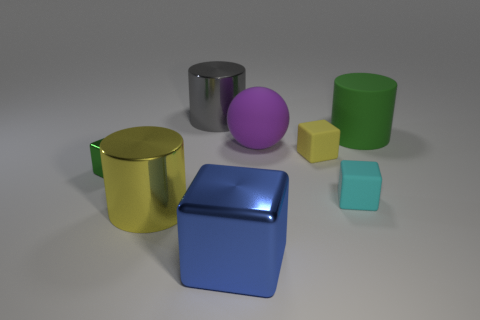Is the number of cyan blocks behind the ball greater than the number of big green cubes?
Offer a very short reply. No. The yellow cylinder that is the same material as the gray object is what size?
Your answer should be compact. Large. What number of other big matte balls have the same color as the sphere?
Provide a short and direct response. 0. There is a metal block to the right of the big yellow metal cylinder; is its color the same as the large matte sphere?
Your answer should be very brief. No. Is the number of blue things that are behind the green block the same as the number of big gray cylinders that are in front of the purple sphere?
Offer a terse response. Yes. Are there any other things that are made of the same material as the purple sphere?
Make the answer very short. Yes. There is a large rubber object in front of the green matte cylinder; what is its color?
Make the answer very short. Purple. Are there the same number of cyan matte blocks that are behind the large gray cylinder and yellow matte objects?
Offer a very short reply. No. What number of other objects are the same shape as the small yellow thing?
Ensure brevity in your answer.  3. There is a rubber cylinder; how many big shiny things are behind it?
Provide a short and direct response. 1. 